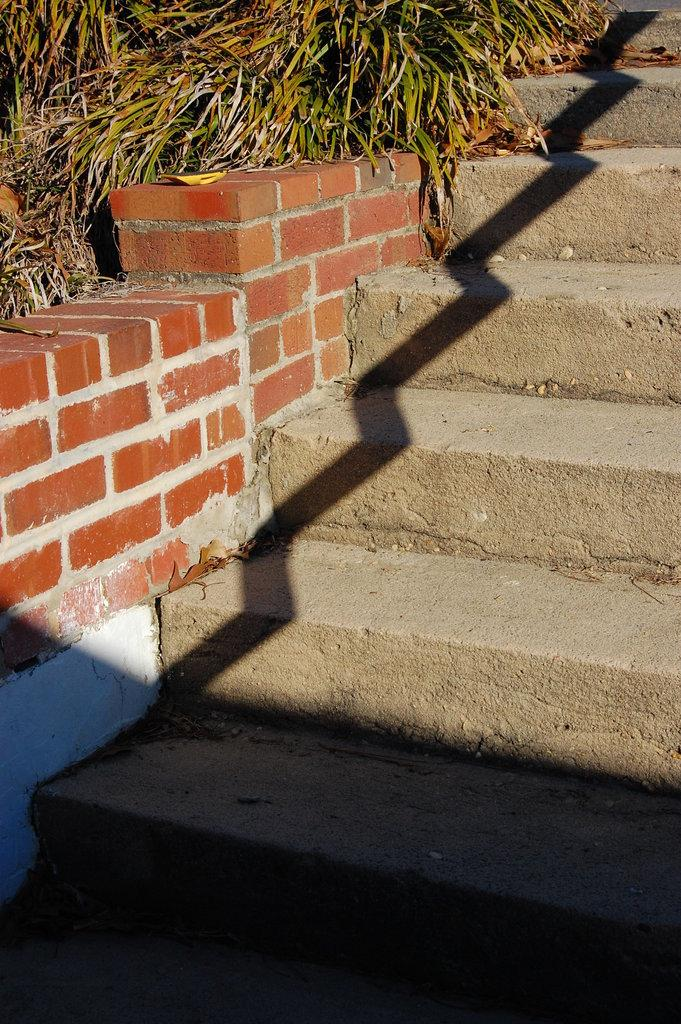What type of stairs are present in the image? There are concrete stairs in the image. What material is used for the wall on the left side of the image? The wall on the left side of the image is made of brick. What type of vegetation can be seen at the top of the image? Grass is visible at the top of the image. What type of cheese is being processed on the stairs in the image? There is no cheese or process present in the image; it features concrete stairs and a brick wall. What force is being applied to the grass at the top of the image? There is no force being applied to the grass in the image; it is simply visible. 